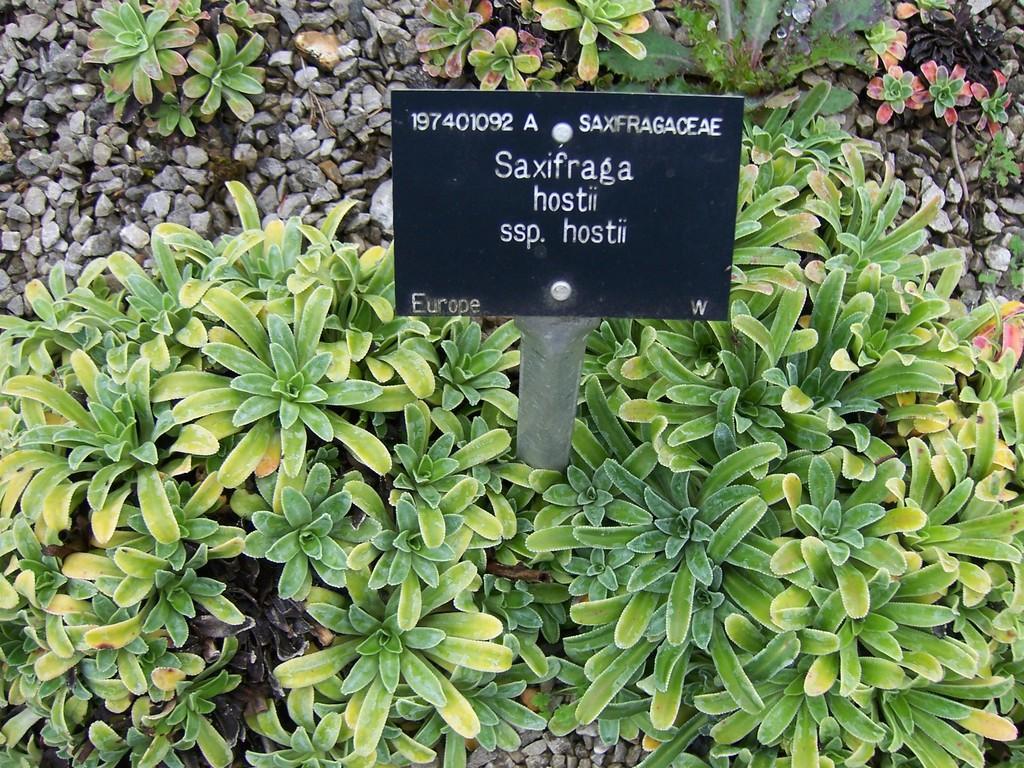Describe this image in one or two sentences. In this picture we can see few plants, stones, metal rod and a board. 